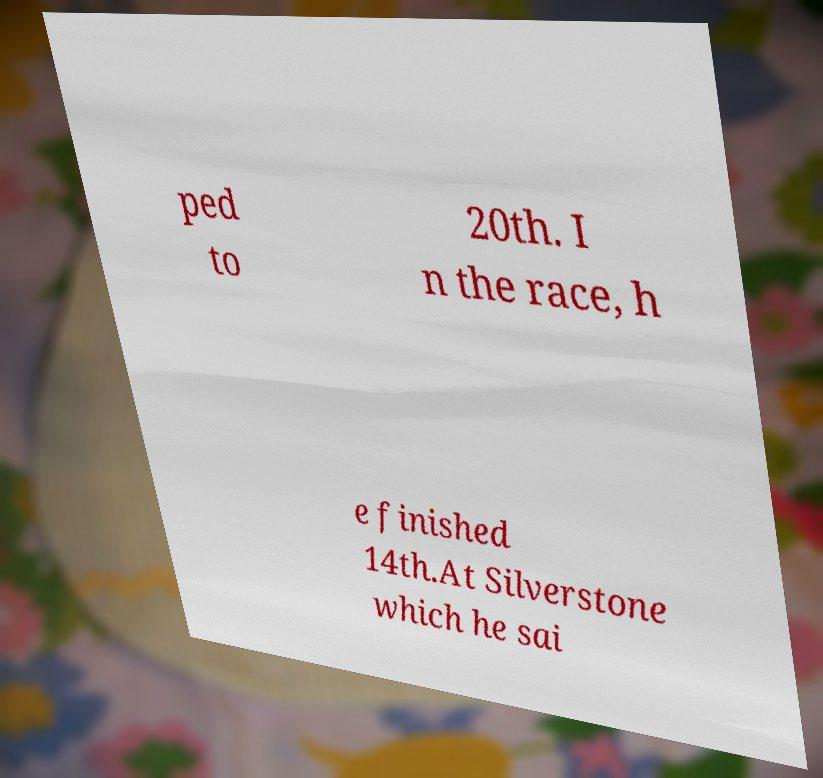What messages or text are displayed in this image? I need them in a readable, typed format. ped to 20th. I n the race, h e finished 14th.At Silverstone which he sai 